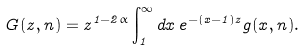Convert formula to latex. <formula><loc_0><loc_0><loc_500><loc_500>G ( z , n ) = z ^ { 1 - 2 \alpha } \int _ { 1 } ^ { \infty } d x \, e ^ { - ( x - 1 ) z } g ( x , n ) .</formula> 